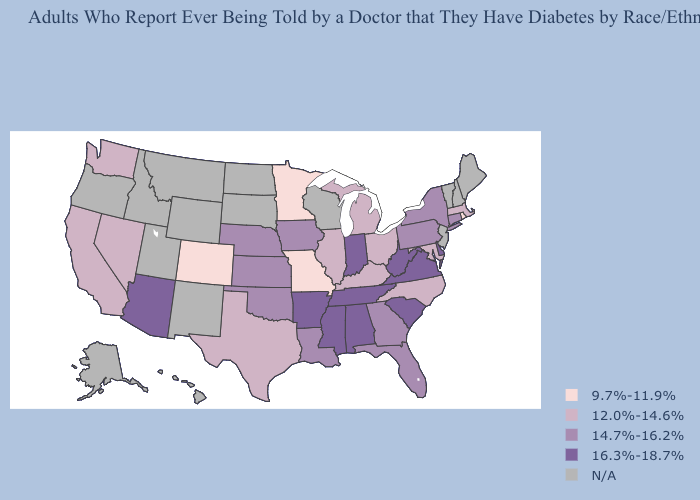What is the highest value in the USA?
Be succinct. 16.3%-18.7%. Name the states that have a value in the range 9.7%-11.9%?
Be succinct. Colorado, Minnesota, Missouri, Rhode Island. Name the states that have a value in the range 14.7%-16.2%?
Quick response, please. Connecticut, Florida, Georgia, Iowa, Kansas, Louisiana, Nebraska, New York, Oklahoma, Pennsylvania. What is the value of Wyoming?
Answer briefly. N/A. What is the lowest value in states that border Louisiana?
Answer briefly. 12.0%-14.6%. What is the value of Alaska?
Keep it brief. N/A. How many symbols are there in the legend?
Write a very short answer. 5. Name the states that have a value in the range 12.0%-14.6%?
Keep it brief. California, Illinois, Kentucky, Maryland, Massachusetts, Michigan, Nevada, North Carolina, Ohio, Texas, Washington. Does Pennsylvania have the lowest value in the Northeast?
Write a very short answer. No. Among the states that border Virginia , does Tennessee have the highest value?
Give a very brief answer. Yes. Name the states that have a value in the range 16.3%-18.7%?
Keep it brief. Alabama, Arizona, Arkansas, Delaware, Indiana, Mississippi, South Carolina, Tennessee, Virginia, West Virginia. Name the states that have a value in the range 16.3%-18.7%?
Answer briefly. Alabama, Arizona, Arkansas, Delaware, Indiana, Mississippi, South Carolina, Tennessee, Virginia, West Virginia. Name the states that have a value in the range 14.7%-16.2%?
Give a very brief answer. Connecticut, Florida, Georgia, Iowa, Kansas, Louisiana, Nebraska, New York, Oklahoma, Pennsylvania. What is the value of Texas?
Give a very brief answer. 12.0%-14.6%. Name the states that have a value in the range 9.7%-11.9%?
Be succinct. Colorado, Minnesota, Missouri, Rhode Island. 